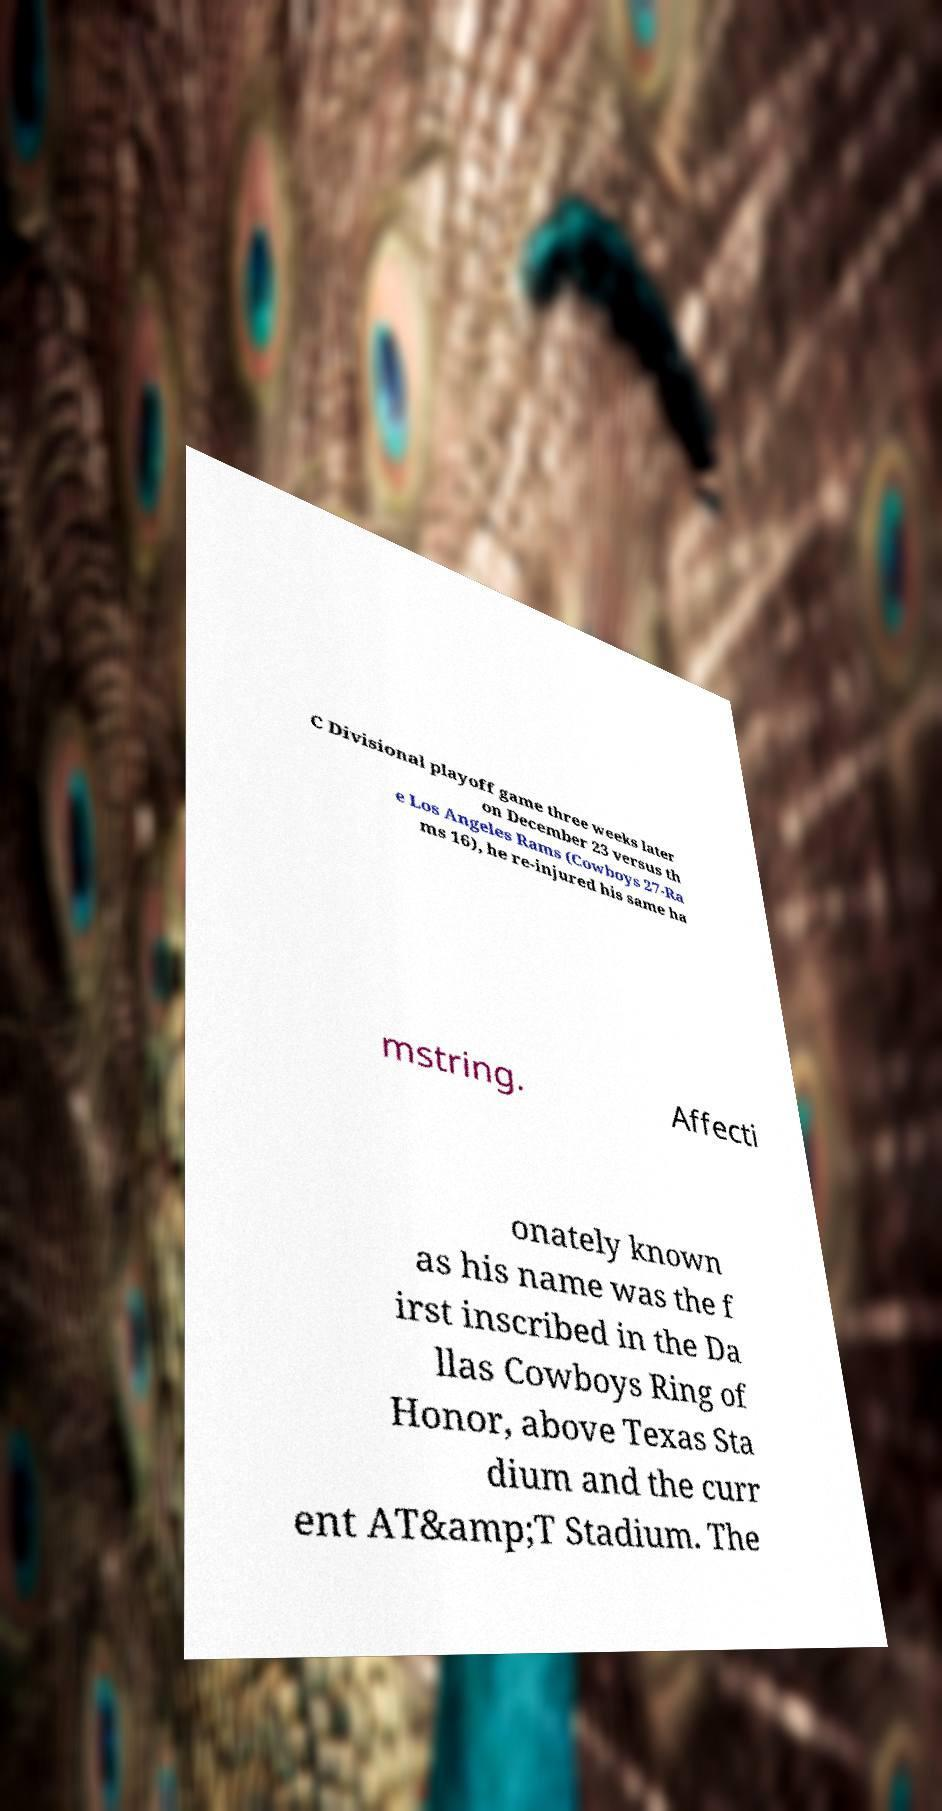What messages or text are displayed in this image? I need them in a readable, typed format. C Divisional playoff game three weeks later on December 23 versus th e Los Angeles Rams (Cowboys 27-Ra ms 16), he re-injured his same ha mstring. Affecti onately known as his name was the f irst inscribed in the Da llas Cowboys Ring of Honor, above Texas Sta dium and the curr ent AT&amp;T Stadium. The 